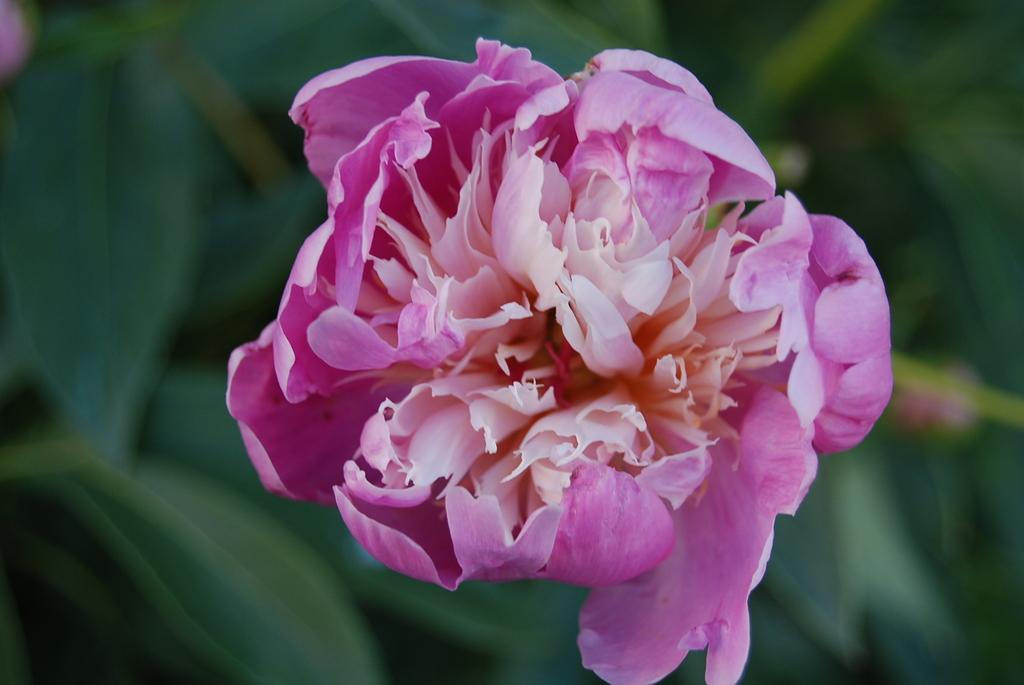What is the main subject of the image? There is a flower in the image. Can you describe the colors of the flower? The flower has pink and cream colors. What can be seen in the background of the image? The background of the image includes plants, but they are blurry. Where can the guitar be found in the image? There is no guitar present in the image. What type of cactus is visible in the image? There is no cactus present in the image. 